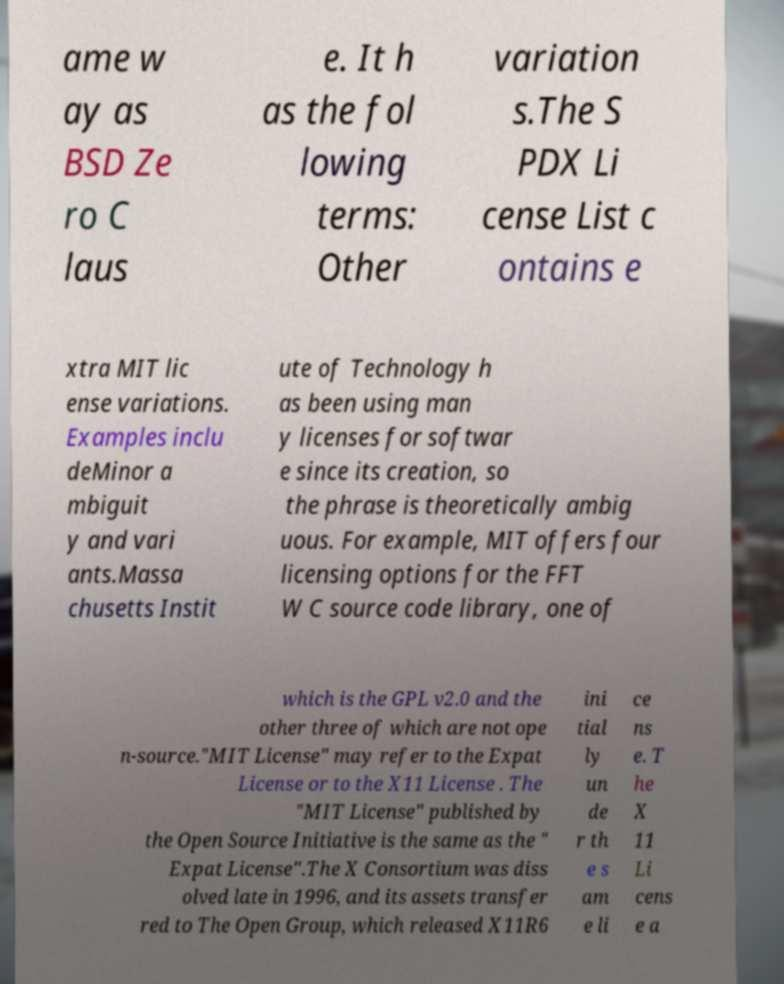Could you assist in decoding the text presented in this image and type it out clearly? ame w ay as BSD Ze ro C laus e. It h as the fol lowing terms: Other variation s.The S PDX Li cense List c ontains e xtra MIT lic ense variations. Examples inclu deMinor a mbiguit y and vari ants.Massa chusetts Instit ute of Technology h as been using man y licenses for softwar e since its creation, so the phrase is theoretically ambig uous. For example, MIT offers four licensing options for the FFT W C source code library, one of which is the GPL v2.0 and the other three of which are not ope n-source."MIT License" may refer to the Expat License or to the X11 License . The "MIT License" published by the Open Source Initiative is the same as the " Expat License".The X Consortium was diss olved late in 1996, and its assets transfer red to The Open Group, which released X11R6 ini tial ly un de r th e s am e li ce ns e. T he X 11 Li cens e a 